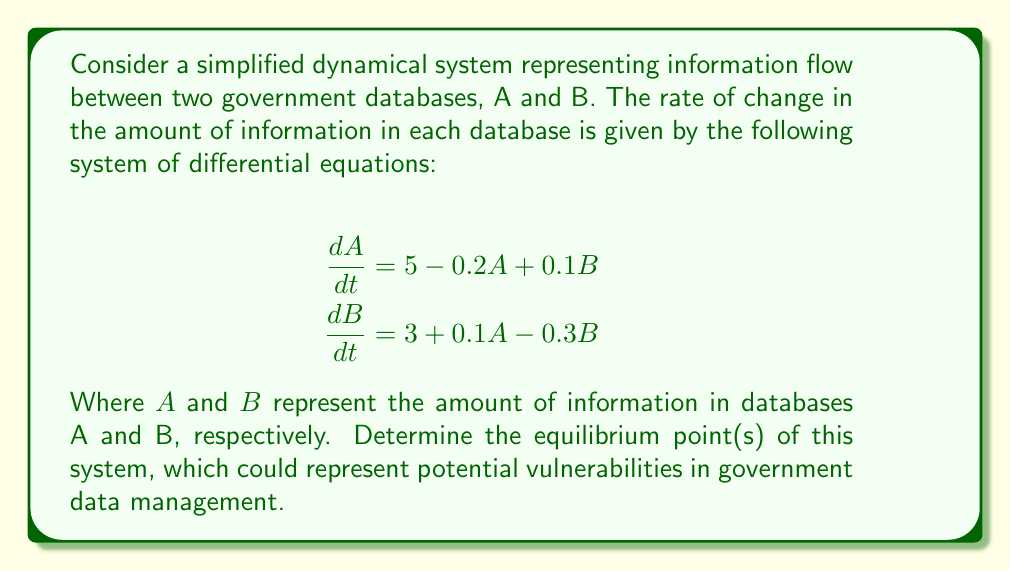Help me with this question. To find the equilibrium points, we need to set both equations equal to zero and solve for A and B:

1) Set $\frac{dA}{dt} = 0$ and $\frac{dB}{dt} = 0$:

   $$\begin{align}
   0 &= 5 - 0.2A + 0.1B \\
   0 &= 3 + 0.1A - 0.3B
   \end{align}$$

2) Rearrange the equations:

   $$\begin{align}
   0.2A - 0.1B &= 5 \\
   -0.1A + 0.3B &= 3
   \end{align}$$

3) Multiply the first equation by 3 and the second equation by 2:

   $$\begin{align}
   0.6A - 0.3B &= 15 \\
   -0.2A + 0.6B &= 6
   \end{align}$$

4) Add these equations to eliminate B:

   $$0.4A = 21$$

5) Solve for A:

   $$A = \frac{21}{0.4} = 52.5$$

6) Substitute this value of A into either of the original equations. Let's use the first one:

   $$\begin{align}
   0 &= 5 - 0.2(52.5) + 0.1B \\
   0 &= 5 - 10.5 + 0.1B \\
   5.5 &= 0.1B \\
   B &= 55
   \end{align}$$

Therefore, the equilibrium point is (52.5, 55).
Answer: (52.5, 55) 